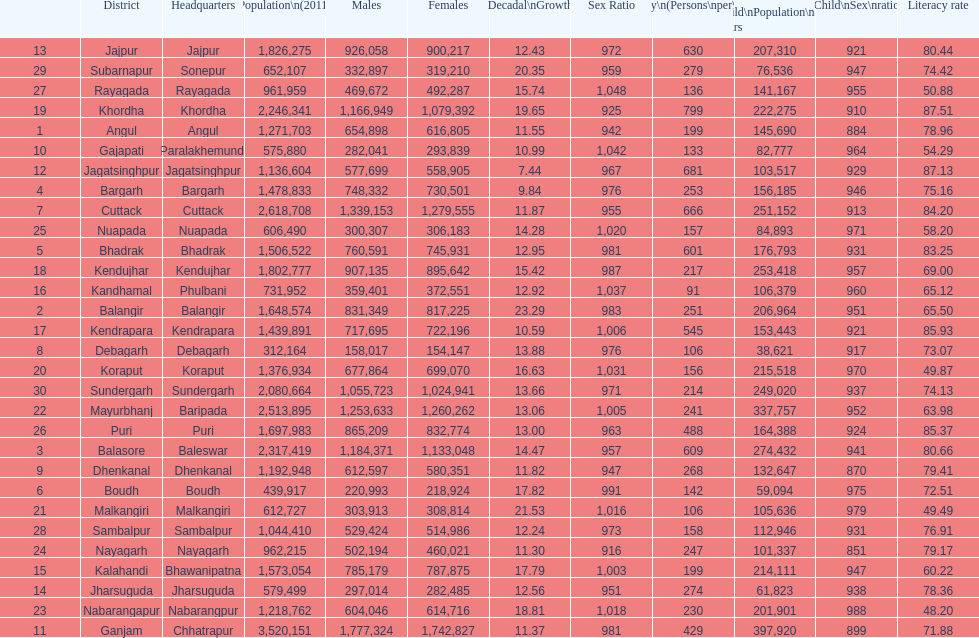Which district had the most people per km? Khordha. 